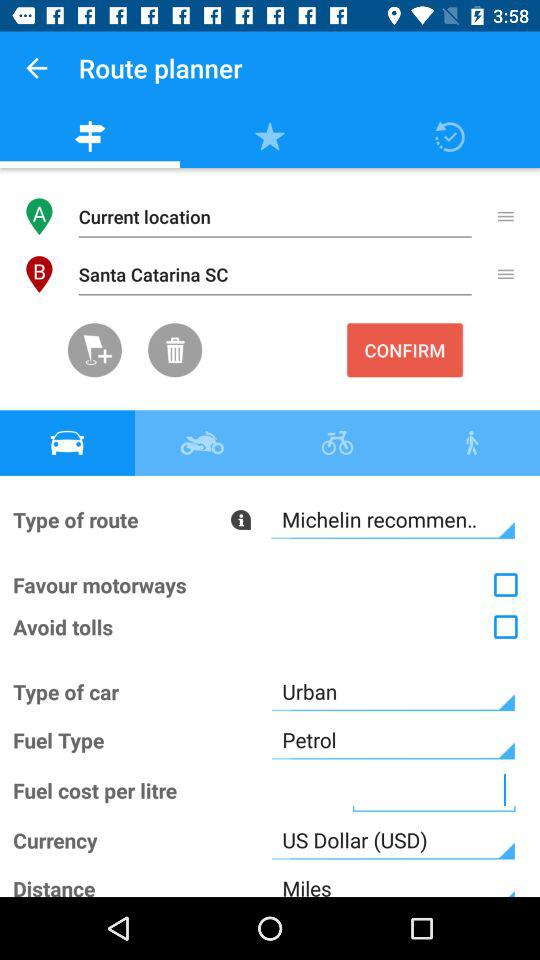What is the type of car? The type of car is "Urban". 